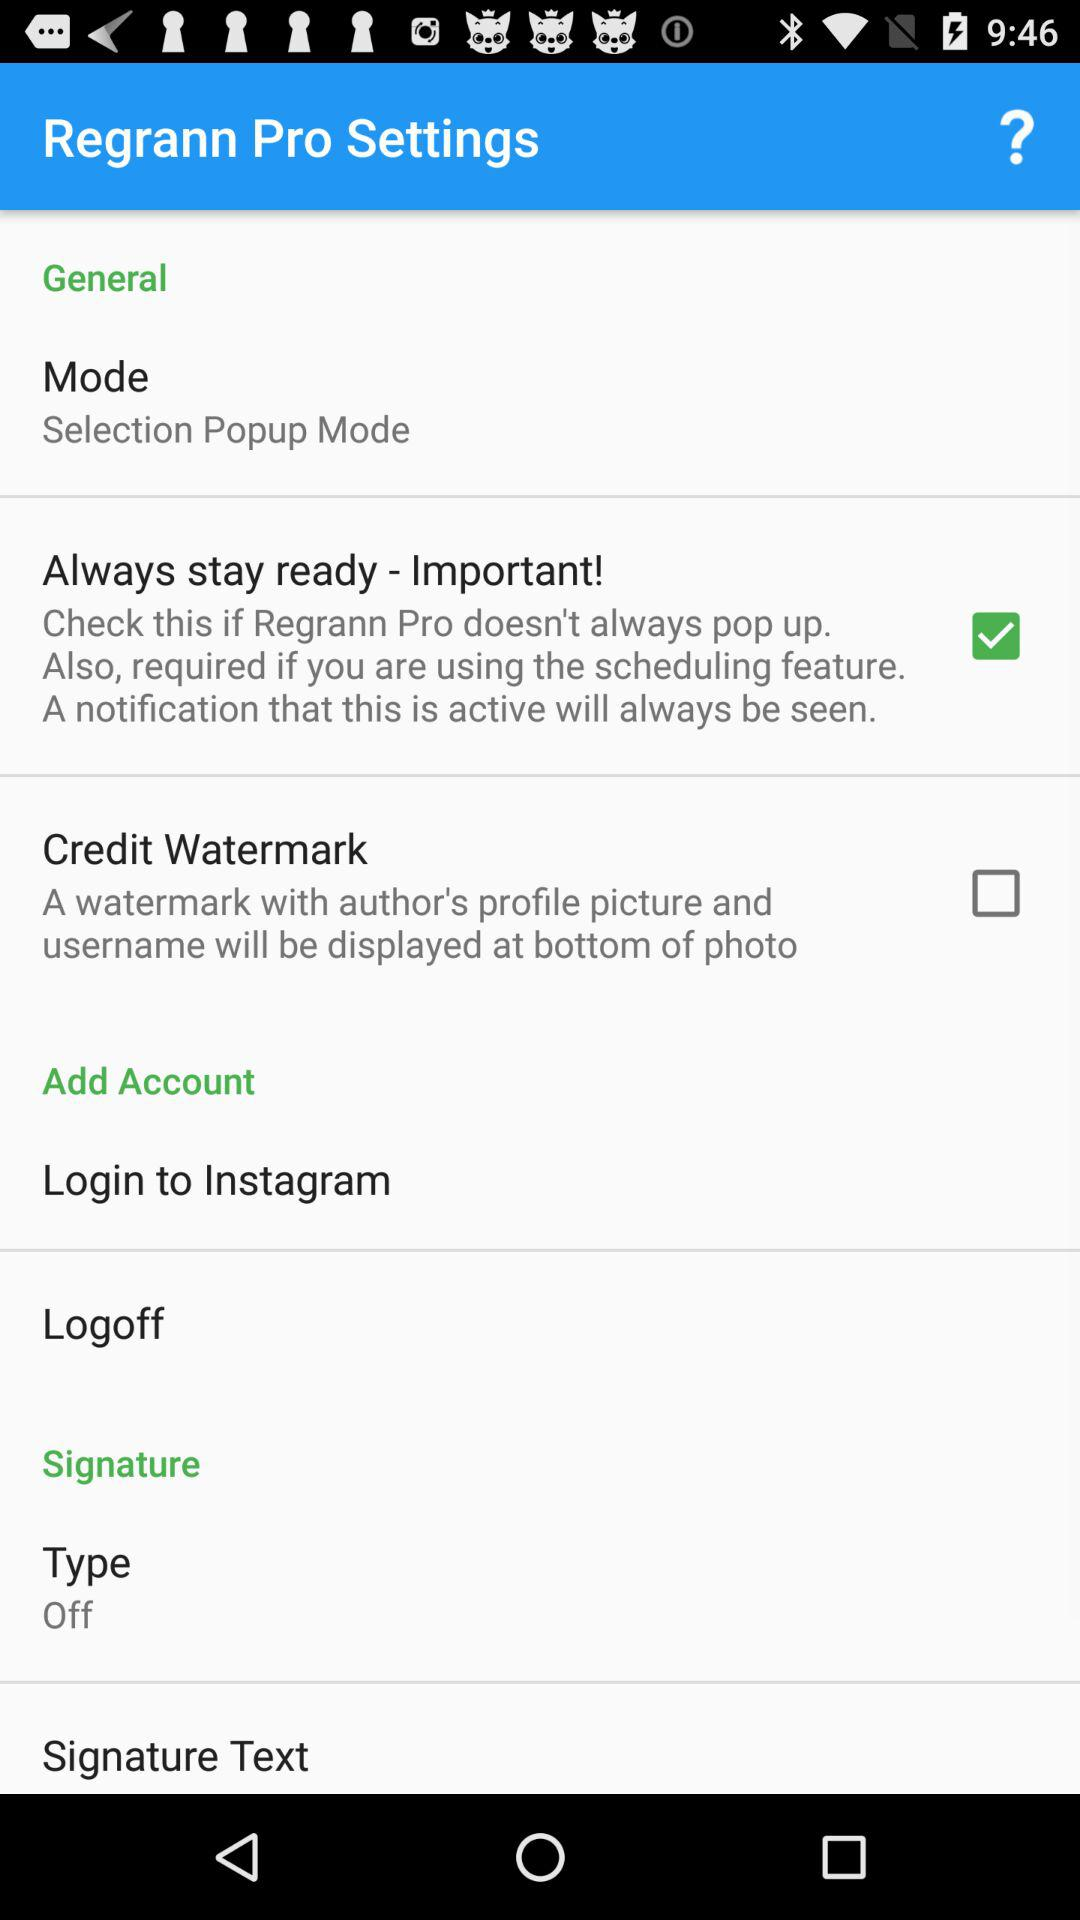What is the status of the "Credit Watermark"? The status is "off". 